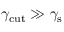<formula> <loc_0><loc_0><loc_500><loc_500>\gamma _ { c u t } \gg \gamma _ { s }</formula> 